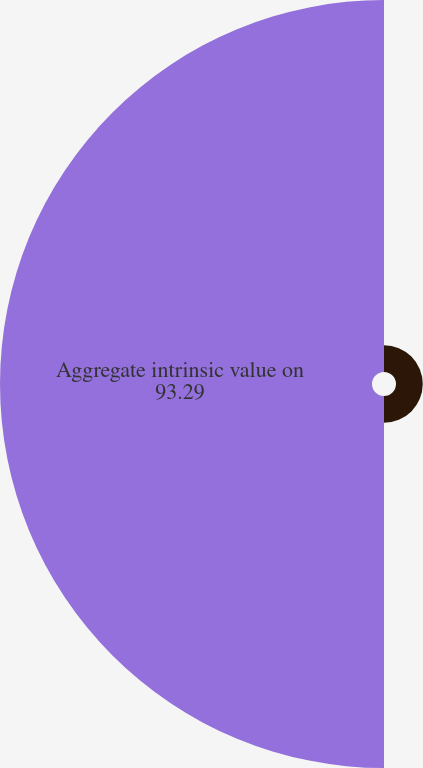Convert chart. <chart><loc_0><loc_0><loc_500><loc_500><pie_chart><fcel>Aggregate exercise proceeds<fcel>Aggregate intrinsic value on<nl><fcel>6.71%<fcel>93.29%<nl></chart> 